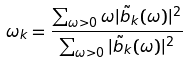Convert formula to latex. <formula><loc_0><loc_0><loc_500><loc_500>\omega _ { k } = \frac { \sum _ { \omega > 0 } \omega | \tilde { b } _ { k } ( \omega ) | ^ { 2 } } { \sum _ { \omega > 0 } | \tilde { b } _ { k } ( \omega ) | ^ { 2 } }</formula> 